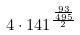Convert formula to latex. <formula><loc_0><loc_0><loc_500><loc_500>4 \cdot 1 4 1 ^ { \frac { \frac { 9 3 } { 4 9 5 } } { 2 } }</formula> 